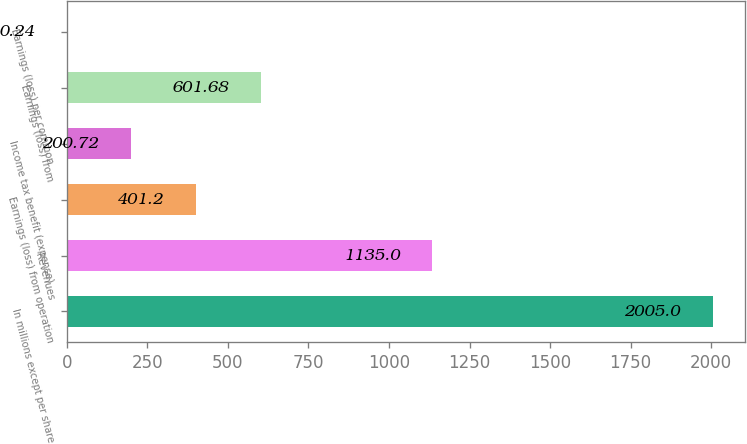<chart> <loc_0><loc_0><loc_500><loc_500><bar_chart><fcel>In millions except per share<fcel>Revenues<fcel>Earnings (loss) from operation<fcel>Income tax benefit (expense)<fcel>Earnings (loss) from<fcel>Earnings (loss) per common<nl><fcel>2005<fcel>1135<fcel>401.2<fcel>200.72<fcel>601.68<fcel>0.24<nl></chart> 